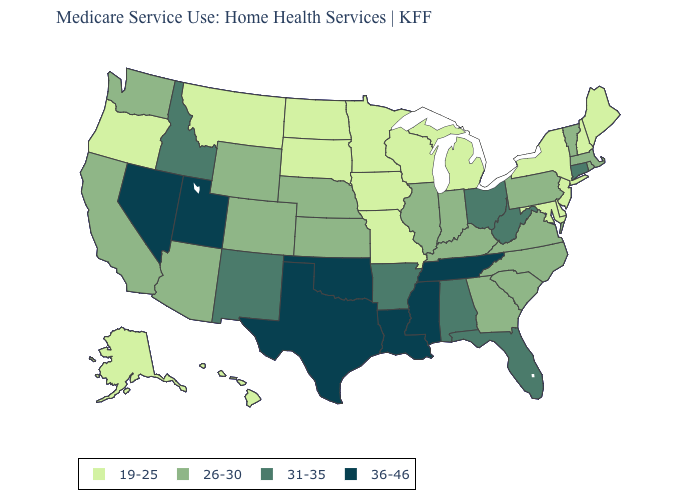What is the lowest value in the USA?
Be succinct. 19-25. What is the lowest value in the West?
Keep it brief. 19-25. What is the value of Idaho?
Give a very brief answer. 31-35. Is the legend a continuous bar?
Short answer required. No. Does New York have the highest value in the Northeast?
Short answer required. No. Name the states that have a value in the range 36-46?
Short answer required. Louisiana, Mississippi, Nevada, Oklahoma, Tennessee, Texas, Utah. Name the states that have a value in the range 19-25?
Be succinct. Alaska, Delaware, Hawaii, Iowa, Maine, Maryland, Michigan, Minnesota, Missouri, Montana, New Hampshire, New Jersey, New York, North Dakota, Oregon, South Dakota, Wisconsin. What is the value of New York?
Be succinct. 19-25. Does Montana have a lower value than Virginia?
Quick response, please. Yes. What is the highest value in the MidWest ?
Keep it brief. 31-35. Among the states that border Wyoming , which have the highest value?
Concise answer only. Utah. Does South Dakota have the highest value in the MidWest?
Keep it brief. No. Among the states that border Oklahoma , does Missouri have the lowest value?
Concise answer only. Yes. Name the states that have a value in the range 36-46?
Be succinct. Louisiana, Mississippi, Nevada, Oklahoma, Tennessee, Texas, Utah. Name the states that have a value in the range 31-35?
Write a very short answer. Alabama, Arkansas, Connecticut, Florida, Idaho, New Mexico, Ohio, West Virginia. 